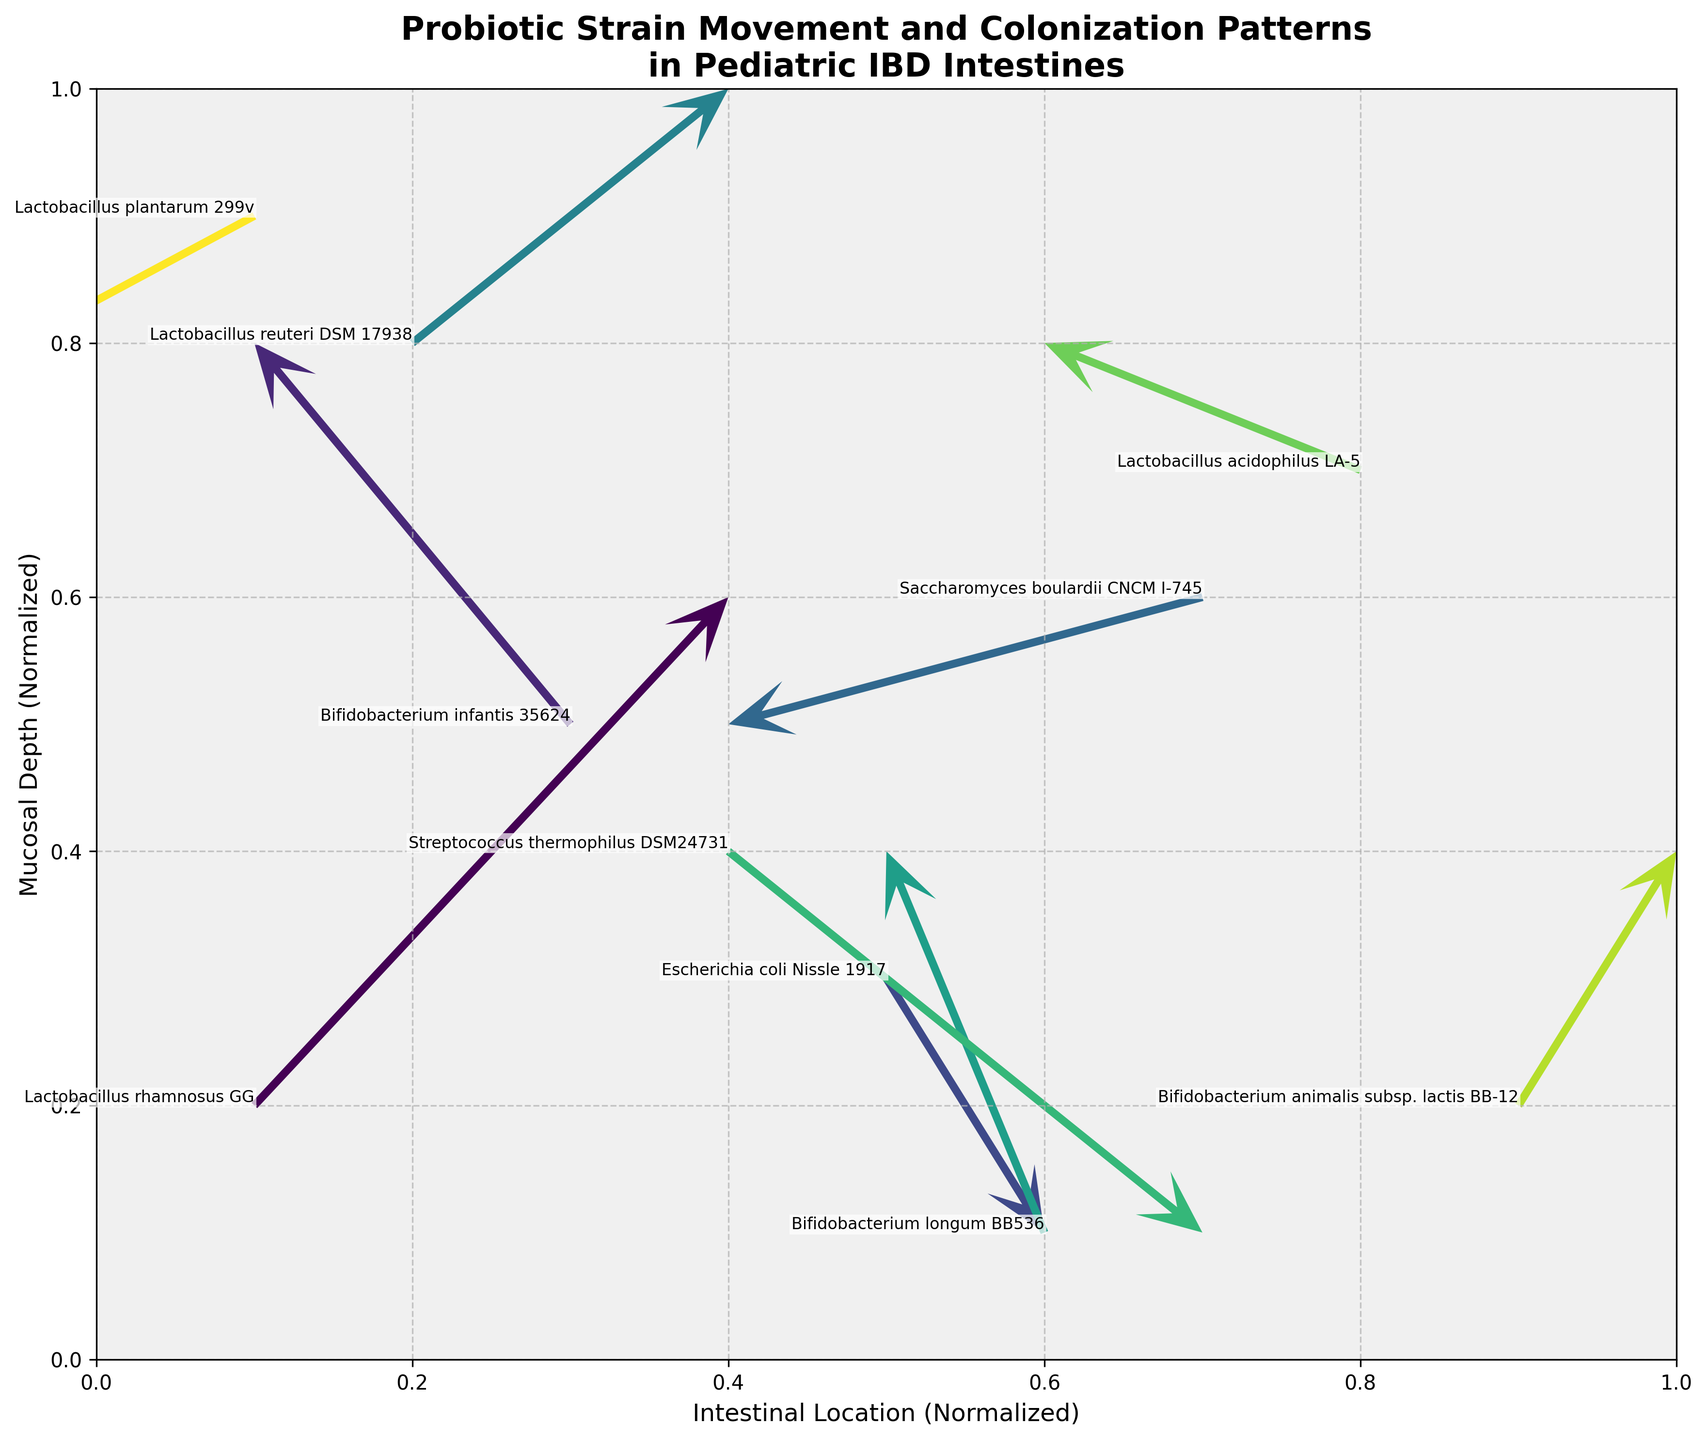What is the title of the figure? The title of the figure is usually found at the top of the plot. It provides an overview of what the plot represents. Reading the largest text at the top of the image typically gives the title.
Answer: Probiotic Strain Movement and Colonization Patterns in Pediatric IBD Intestines How many probiotic strains are plotted in the figure? To find out the number of probiotic strains, count the different arrows indicated in the plot. Each arrow is paired with a label that names the strain.
Answer: 10 What are the axes labels in the figure? Axes labels are found next to the horizontal and vertical axes of the plot. They describe what each axis represents.
Answer: Intestinal Location (Normalized) and Mucosal Depth (Normalized) Which probiotic strain shows the longest arrow in terms of combined movement in x and y directions? To determine this, calculate the combined movement for each arrow using the Pythagorean theorem (sqrt(u^2 + v^2)). The arrow with the highest value corresponds to the longest movement.
Answer: Lactobacillus rhamnosus GG What is the direction of movement for Lactobacillus plantarum 299v? To determine this, look at the start and end points of the arrow associated with Lactobacillus plantarum 299v. The direction is indicated by the arrowhead.
Answer: Down and to the left Which strain shows movement in the negative x-direction but positive y-direction? To identify this, look for an arrow pointing left (negative x) and upwards (positive y).
Answer: Bifidobacterium infantis 35624 Compare the movements of Lactobacillus reuteri DSM 17938 and Bifidobacterium longum BB536. Which one moves more vertically? First, identify the u and v components for both strains. Then, compare the absolute values of their v components (vertical movement) to see which one has the larger value.
Answer: Bifidobacterium longum BB536 Which strain has the arrow with the largest horizontal movement? To identify this, look for the strain where the u component of their movement vector has the highest magnitude, regardless of direction.
Answer: Lactobacillus rhamnosus GG What are the coordinates of the arrowhead of Lactobacillus acidophilus LA-5? The arrowhead coordinates can be calculated by adding the movement vector components to the starting point (x, y). For Lactobacillus acidophilus LA-5, they are: (0.8, 0.7) + (-0.2, 0.1) = (0.6, 0.8).
Answer: (0.6, 0.8) Which strain moves downward and to the right? Look for the strain where the v component (vertical movement) is negative and the u component (horizontal movement) is positive.
Answer: Escherichia coli Nissle 1917 